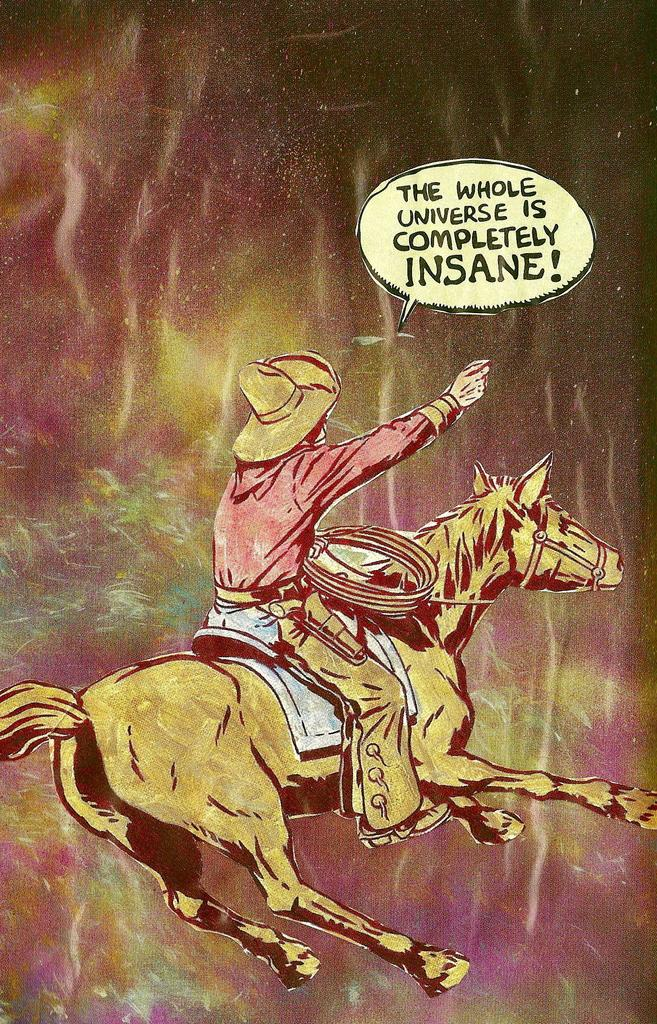What is depicted in the picture? There is an art work in the picture. What is the man in the art work doing? A man is sitting on a horse in the art work. What is the man holding in the art work? The man is holding a rope in the art work. Can you describe the color scheme of the art work? There are multiple colors visible in the art work. Is there any text present in the art work? Yes, there is text present in the art work. What type of cream is being applied to the dog in the image? There is no dog or cream present in the image; it features an art work with a man sitting on a horse. 